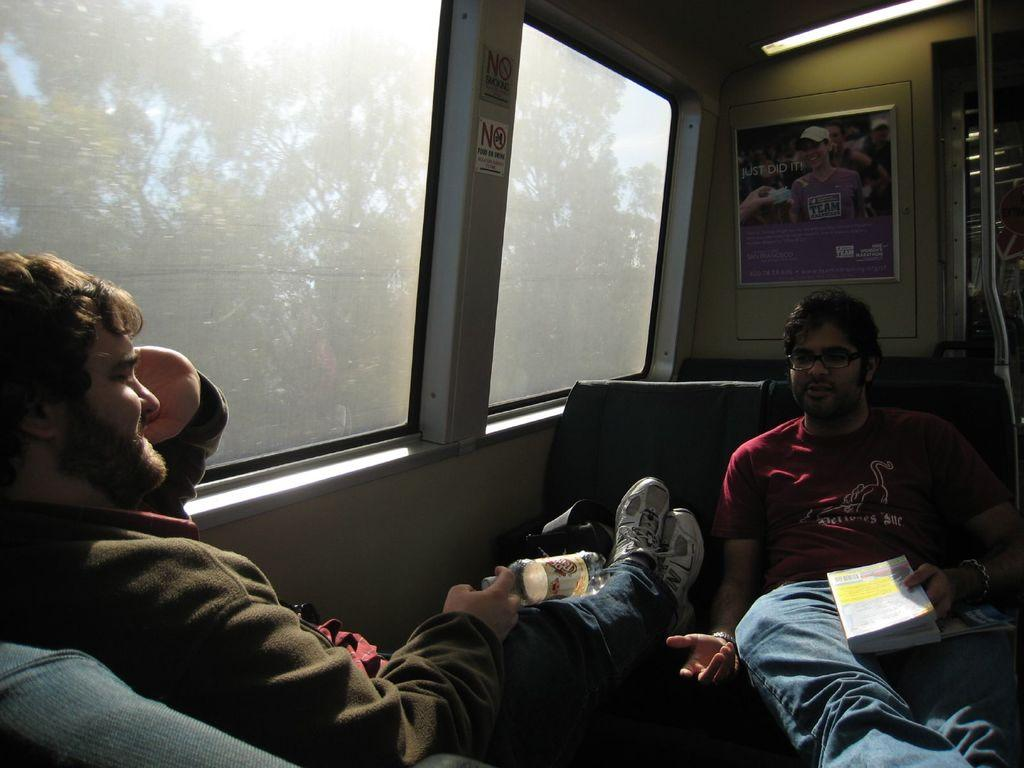How many people are sitting on the sofa in the image? There are two people sitting on the sofa in the image. What can be seen on the wall in the image? There is a poster on the wall in the image. Where is the window located in the image? The window is on the right side of the image. What is visible through the window in the image? Trees are visible through the window in the image. What is visible in the background of the image? The sky is visible in the image. What type of soup is being served to the grandmother in the image? There is no grandmother or soup present in the image. 